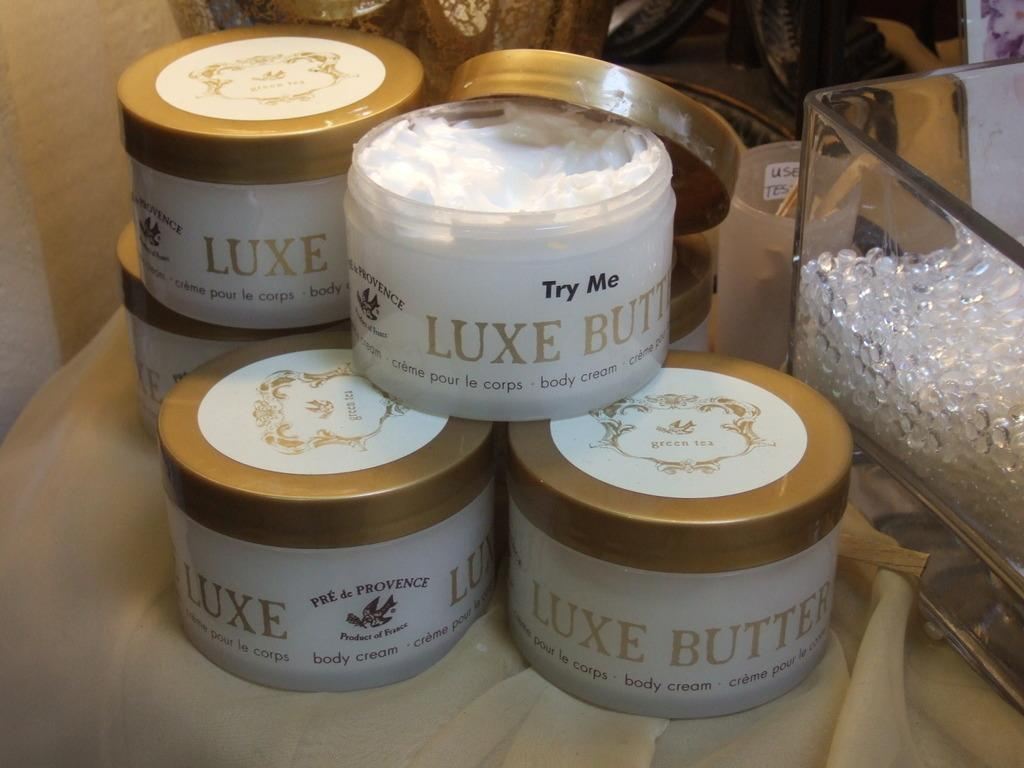Provide a one-sentence caption for the provided image. Body cream boxes in the brand name of Luxe butter. 